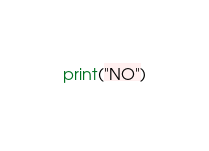Convert code to text. <code><loc_0><loc_0><loc_500><loc_500><_Python_>print("NO")</code> 